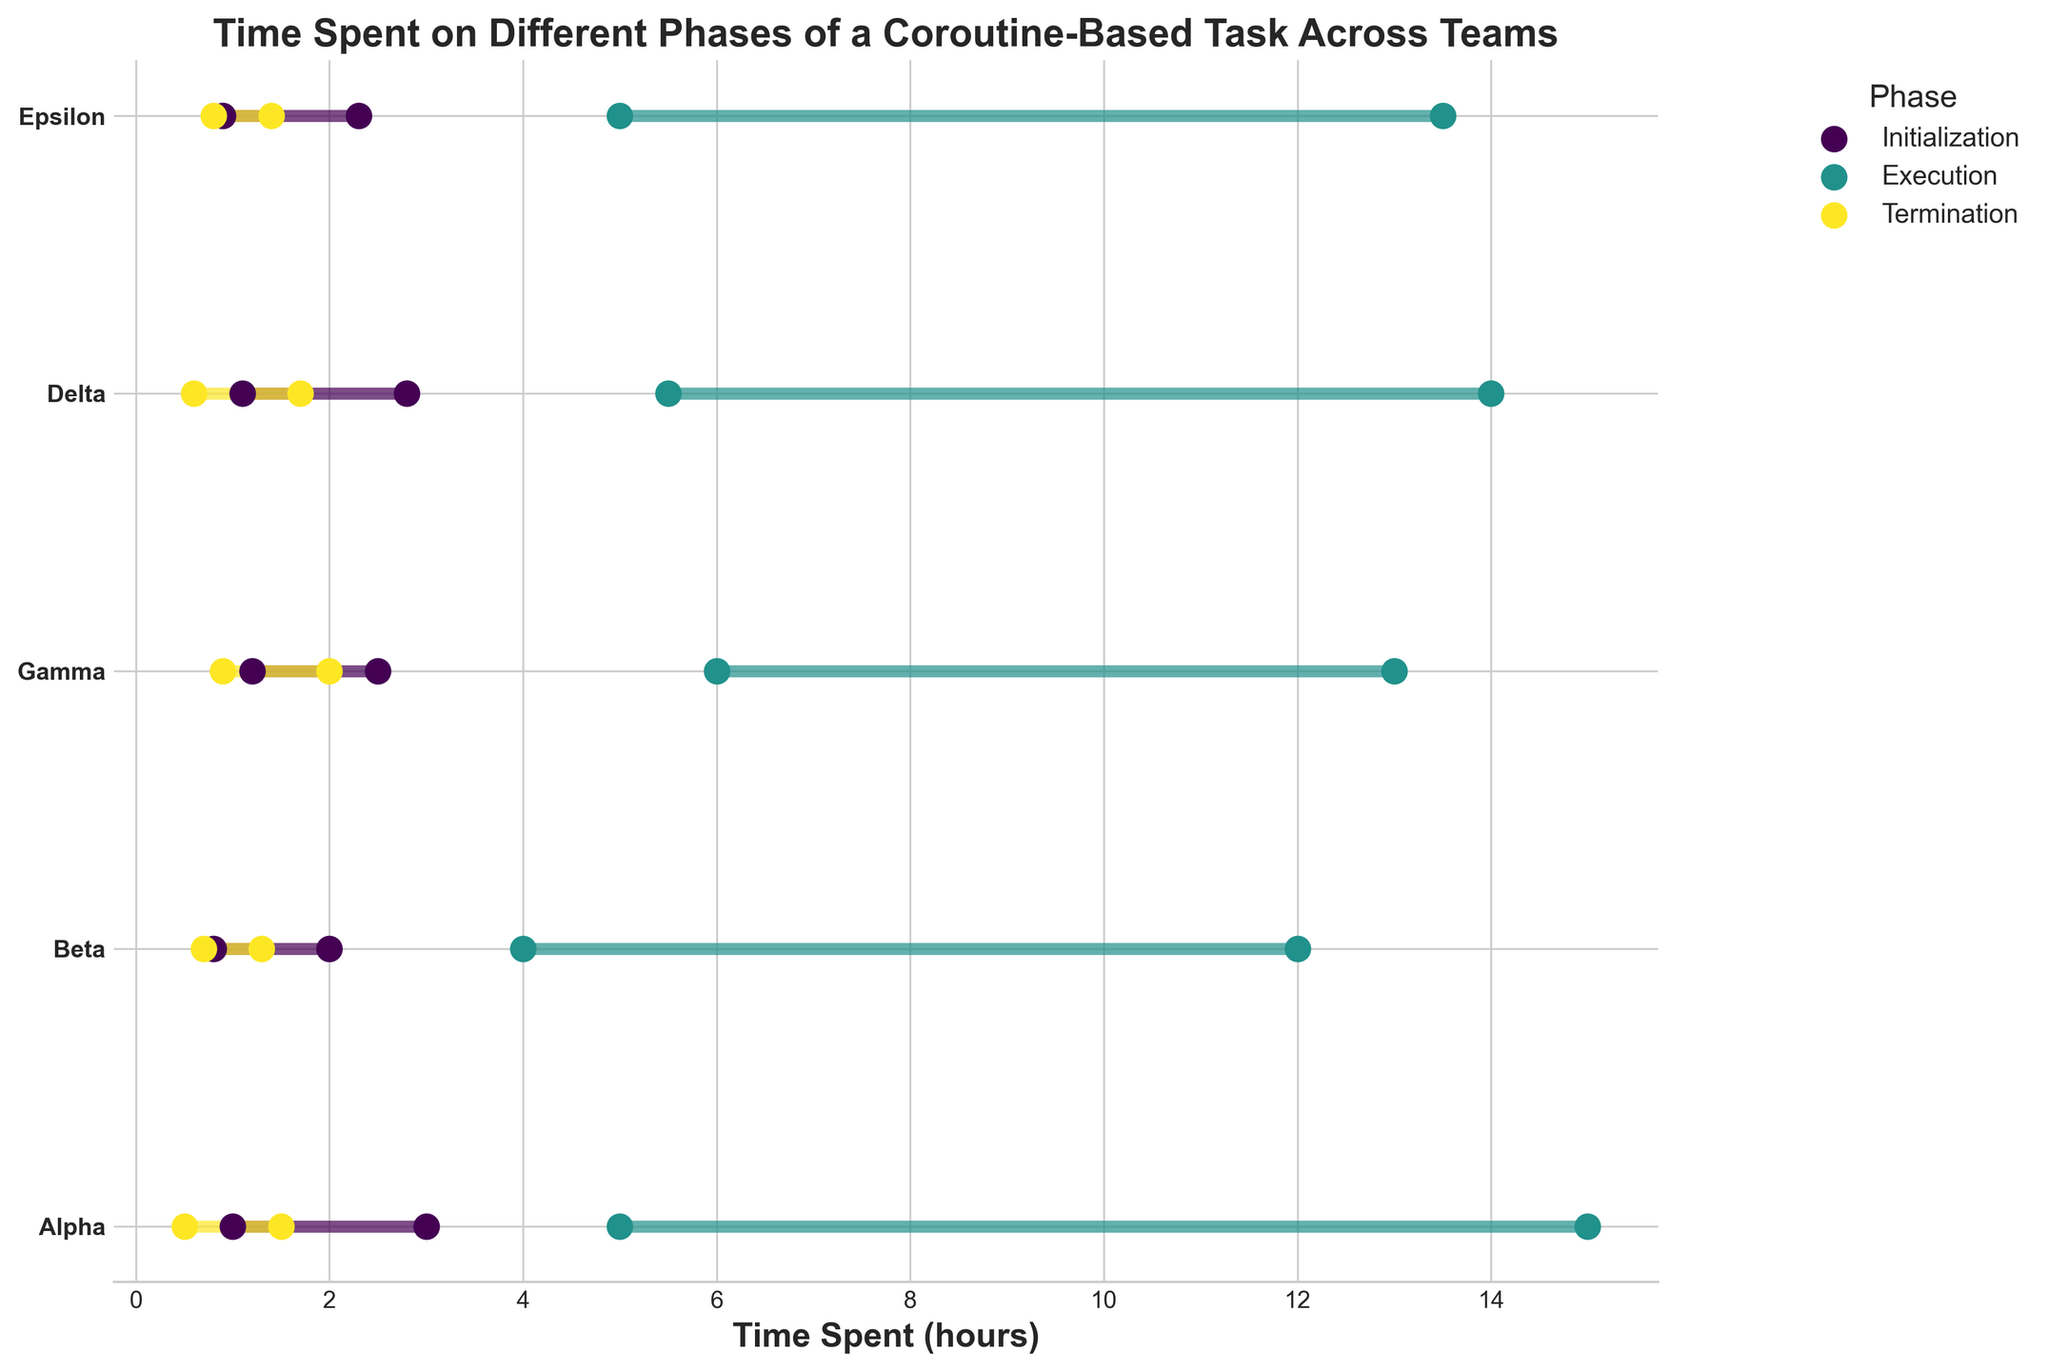What is the title of the plot? The title of the plot is displayed at the top, indicating the subject of the data visualization.
Answer: Time Spent on Different Phases of a Coroutine-Based Task Across Teams Which team spent the least maximum time on Initialization? By looking at the maximum time values for the Initialization phase for all teams, the team with the smallest maximum time can be identified.
Answer: Beta What is the range of time spent on the Execution phase by Team Alpha? The range is determined by the difference between the maximum and minimum times. For Team Alpha, the minimum time is 5 hours, and the maximum time is 15 hours. Thus, the range is 15 - 5.
Answer: 10 hours How does Team Gamma’s maximum time spent on Termination compare to Team Delta’s maximum time spent on the same phase? By comparing the maximum times for the Termination phase between Team Gamma and Team Delta. Gamma has a maximum time of 2 hours, and Delta has 1.7 hours.
Answer: Team Gamma's maximum time is greater than Team Delta's What is the average minimum time spent on Initialization across all teams? The average is calculated by summing the minimum times for Initialization phase across all teams and dividing by the number of teams: (1 + 0.8 + 1.2 + 1.1 + 0.9) / 5.
Answer: 1 hour Which phase has the most significant difference between the minimum and maximum times for Team Epsilon? By calculating the difference between the maximum and minimum times for each phase for Team Epsilon: Initialization (2.3 - 0.9), Execution (13.5 - 5), Termination (1.4 - 0.8). The Execution phase has the biggest difference.
Answer: Execution Which team has the smallest spread (difference between the min and max times) for the Termination phase? By comparing the difference between the min and max times for the Termination phase across all teams: Alpha (1), Beta (0.6), Gamma (1.1), Delta (1.1), Epsilon (0.6). Both Beta and Epsilon have the smallest spread.
Answer: Beta and Epsilon Is there a phase where all teams have a maximum time greater than 10 hours? Check the maximum times for each team for each phase to see if there is any phase that meets the condition. For Execution, all teams have maximum times over 10 hours (Alpha 15, Beta 12, Gamma 13, Delta 14, Epsilon 13.5).
Answer: Execution How much longer does Team Alpha spend on Execution at maximum compared to Termination at maximum? Subtract the maximum termination time from the maximum execution time for Team Alpha: 15 - 1.5.
Answer: 13.5 hours 